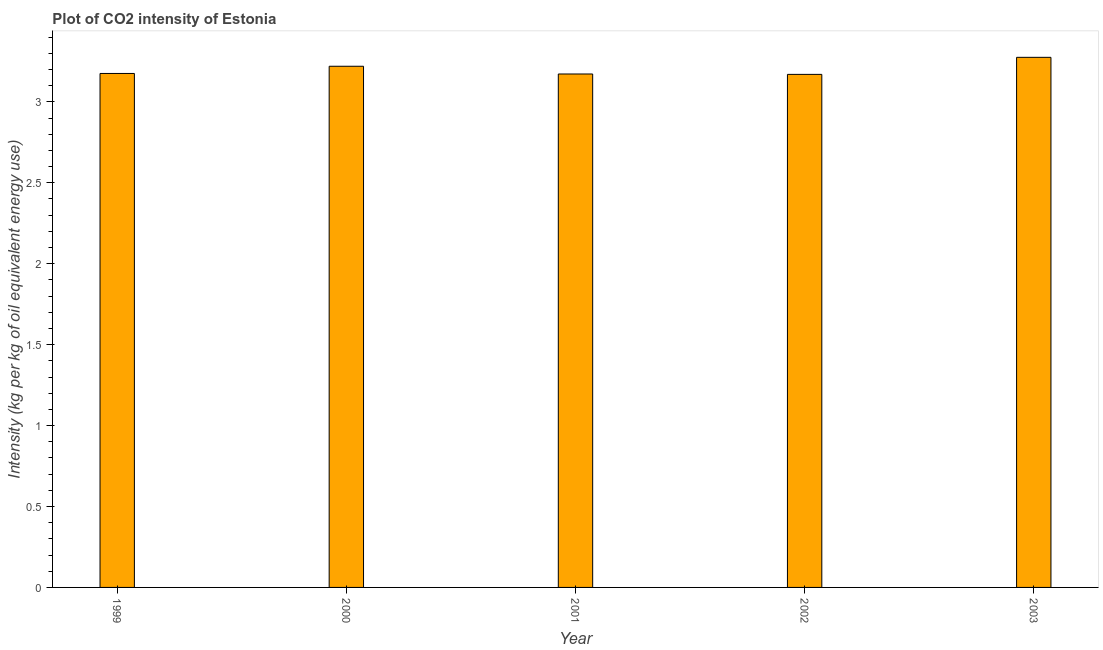Does the graph contain any zero values?
Your response must be concise. No. What is the title of the graph?
Make the answer very short. Plot of CO2 intensity of Estonia. What is the label or title of the Y-axis?
Your answer should be compact. Intensity (kg per kg of oil equivalent energy use). What is the co2 intensity in 2001?
Ensure brevity in your answer.  3.17. Across all years, what is the maximum co2 intensity?
Make the answer very short. 3.28. Across all years, what is the minimum co2 intensity?
Give a very brief answer. 3.17. In which year was the co2 intensity maximum?
Give a very brief answer. 2003. In which year was the co2 intensity minimum?
Keep it short and to the point. 2002. What is the sum of the co2 intensity?
Provide a short and direct response. 16.01. What is the difference between the co2 intensity in 2001 and 2003?
Make the answer very short. -0.1. What is the average co2 intensity per year?
Make the answer very short. 3.2. What is the median co2 intensity?
Your response must be concise. 3.18. Is the difference between the co2 intensity in 1999 and 2002 greater than the difference between any two years?
Offer a terse response. No. What is the difference between the highest and the second highest co2 intensity?
Provide a short and direct response. 0.06. What is the difference between the highest and the lowest co2 intensity?
Provide a short and direct response. 0.11. How many bars are there?
Offer a very short reply. 5. How many years are there in the graph?
Your response must be concise. 5. What is the difference between two consecutive major ticks on the Y-axis?
Provide a succinct answer. 0.5. Are the values on the major ticks of Y-axis written in scientific E-notation?
Provide a succinct answer. No. What is the Intensity (kg per kg of oil equivalent energy use) of 1999?
Offer a very short reply. 3.18. What is the Intensity (kg per kg of oil equivalent energy use) in 2000?
Your answer should be very brief. 3.22. What is the Intensity (kg per kg of oil equivalent energy use) of 2001?
Provide a succinct answer. 3.17. What is the Intensity (kg per kg of oil equivalent energy use) of 2002?
Offer a very short reply. 3.17. What is the Intensity (kg per kg of oil equivalent energy use) in 2003?
Offer a very short reply. 3.28. What is the difference between the Intensity (kg per kg of oil equivalent energy use) in 1999 and 2000?
Offer a very short reply. -0.04. What is the difference between the Intensity (kg per kg of oil equivalent energy use) in 1999 and 2001?
Offer a very short reply. 0. What is the difference between the Intensity (kg per kg of oil equivalent energy use) in 1999 and 2002?
Offer a very short reply. 0.01. What is the difference between the Intensity (kg per kg of oil equivalent energy use) in 1999 and 2003?
Make the answer very short. -0.1. What is the difference between the Intensity (kg per kg of oil equivalent energy use) in 2000 and 2001?
Provide a short and direct response. 0.05. What is the difference between the Intensity (kg per kg of oil equivalent energy use) in 2000 and 2002?
Provide a succinct answer. 0.05. What is the difference between the Intensity (kg per kg of oil equivalent energy use) in 2000 and 2003?
Your response must be concise. -0.06. What is the difference between the Intensity (kg per kg of oil equivalent energy use) in 2001 and 2002?
Provide a short and direct response. 0. What is the difference between the Intensity (kg per kg of oil equivalent energy use) in 2001 and 2003?
Provide a succinct answer. -0.1. What is the difference between the Intensity (kg per kg of oil equivalent energy use) in 2002 and 2003?
Make the answer very short. -0.11. What is the ratio of the Intensity (kg per kg of oil equivalent energy use) in 1999 to that in 2001?
Offer a terse response. 1. What is the ratio of the Intensity (kg per kg of oil equivalent energy use) in 1999 to that in 2002?
Offer a terse response. 1. What is the ratio of the Intensity (kg per kg of oil equivalent energy use) in 1999 to that in 2003?
Your answer should be compact. 0.97. What is the ratio of the Intensity (kg per kg of oil equivalent energy use) in 2000 to that in 2003?
Your response must be concise. 0.98. What is the ratio of the Intensity (kg per kg of oil equivalent energy use) in 2001 to that in 2003?
Your answer should be compact. 0.97. What is the ratio of the Intensity (kg per kg of oil equivalent energy use) in 2002 to that in 2003?
Make the answer very short. 0.97. 